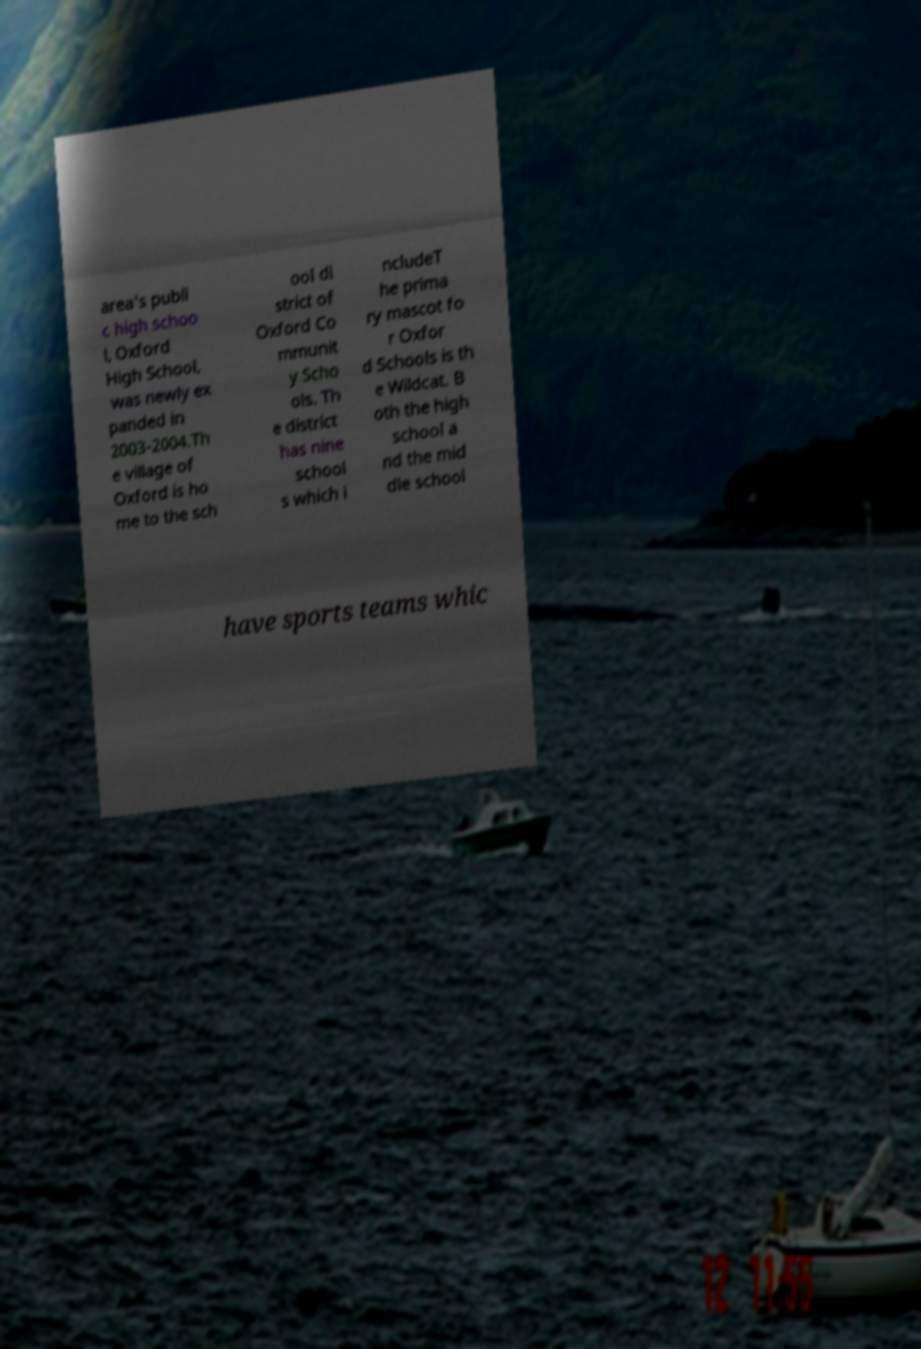Please read and relay the text visible in this image. What does it say? area's publi c high schoo l, Oxford High School, was newly ex panded in 2003-2004.Th e village of Oxford is ho me to the sch ool di strict of Oxford Co mmunit y Scho ols. Th e district has nine school s which i ncludeT he prima ry mascot fo r Oxfor d Schools is th e Wildcat. B oth the high school a nd the mid dle school have sports teams whic 